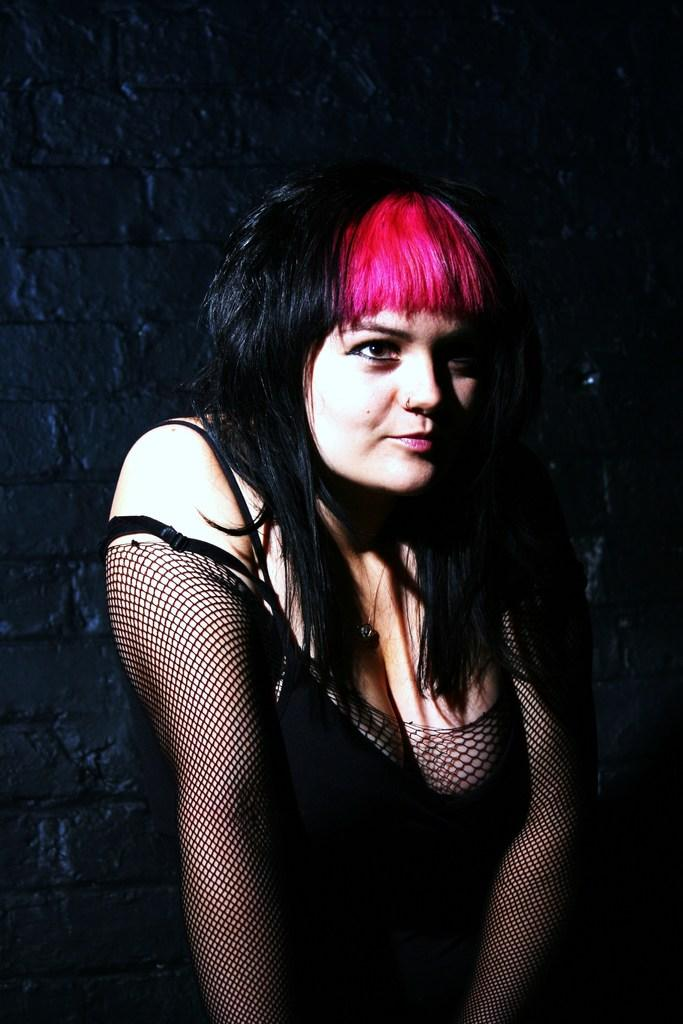Who is present in the image? There is a woman in the image. What is the woman wearing? The woman is wearing a dress. What can be seen in the background of the image? There is a wall in the background of the image. What type of ant can be seen crawling on the woman's dress in the image? There are no ants present in the image, and therefore no such activity can be observed. 